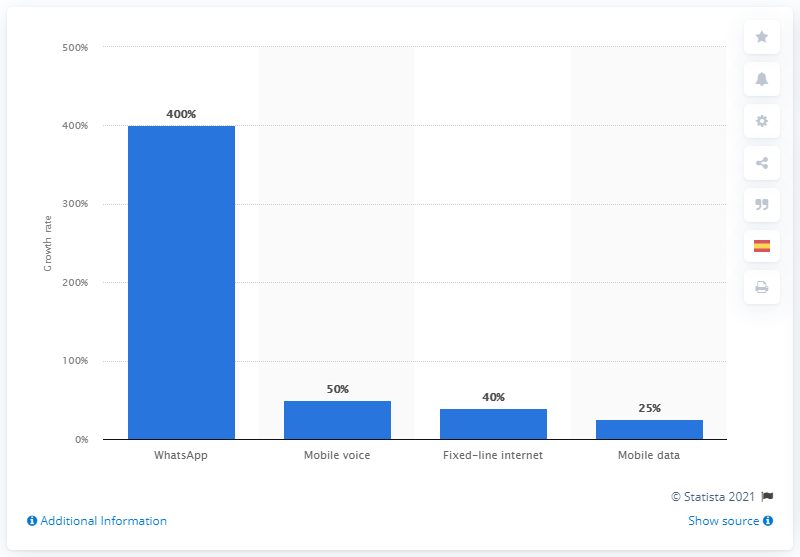Specify some key components in this picture. The mobile internet usage was forecasted to increase by 25% in the future. The projected increase in the use of fixed-line internet was expected to be 40%. 